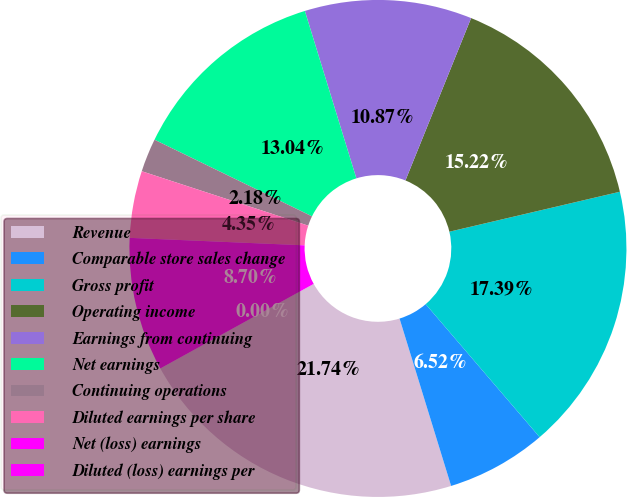<chart> <loc_0><loc_0><loc_500><loc_500><pie_chart><fcel>Revenue<fcel>Comparable store sales change<fcel>Gross profit<fcel>Operating income<fcel>Earnings from continuing<fcel>Net earnings<fcel>Continuing operations<fcel>Diluted earnings per share<fcel>Net (loss) earnings<fcel>Diluted (loss) earnings per<nl><fcel>21.74%<fcel>6.52%<fcel>17.39%<fcel>15.22%<fcel>10.87%<fcel>13.04%<fcel>2.18%<fcel>4.35%<fcel>8.7%<fcel>0.0%<nl></chart> 